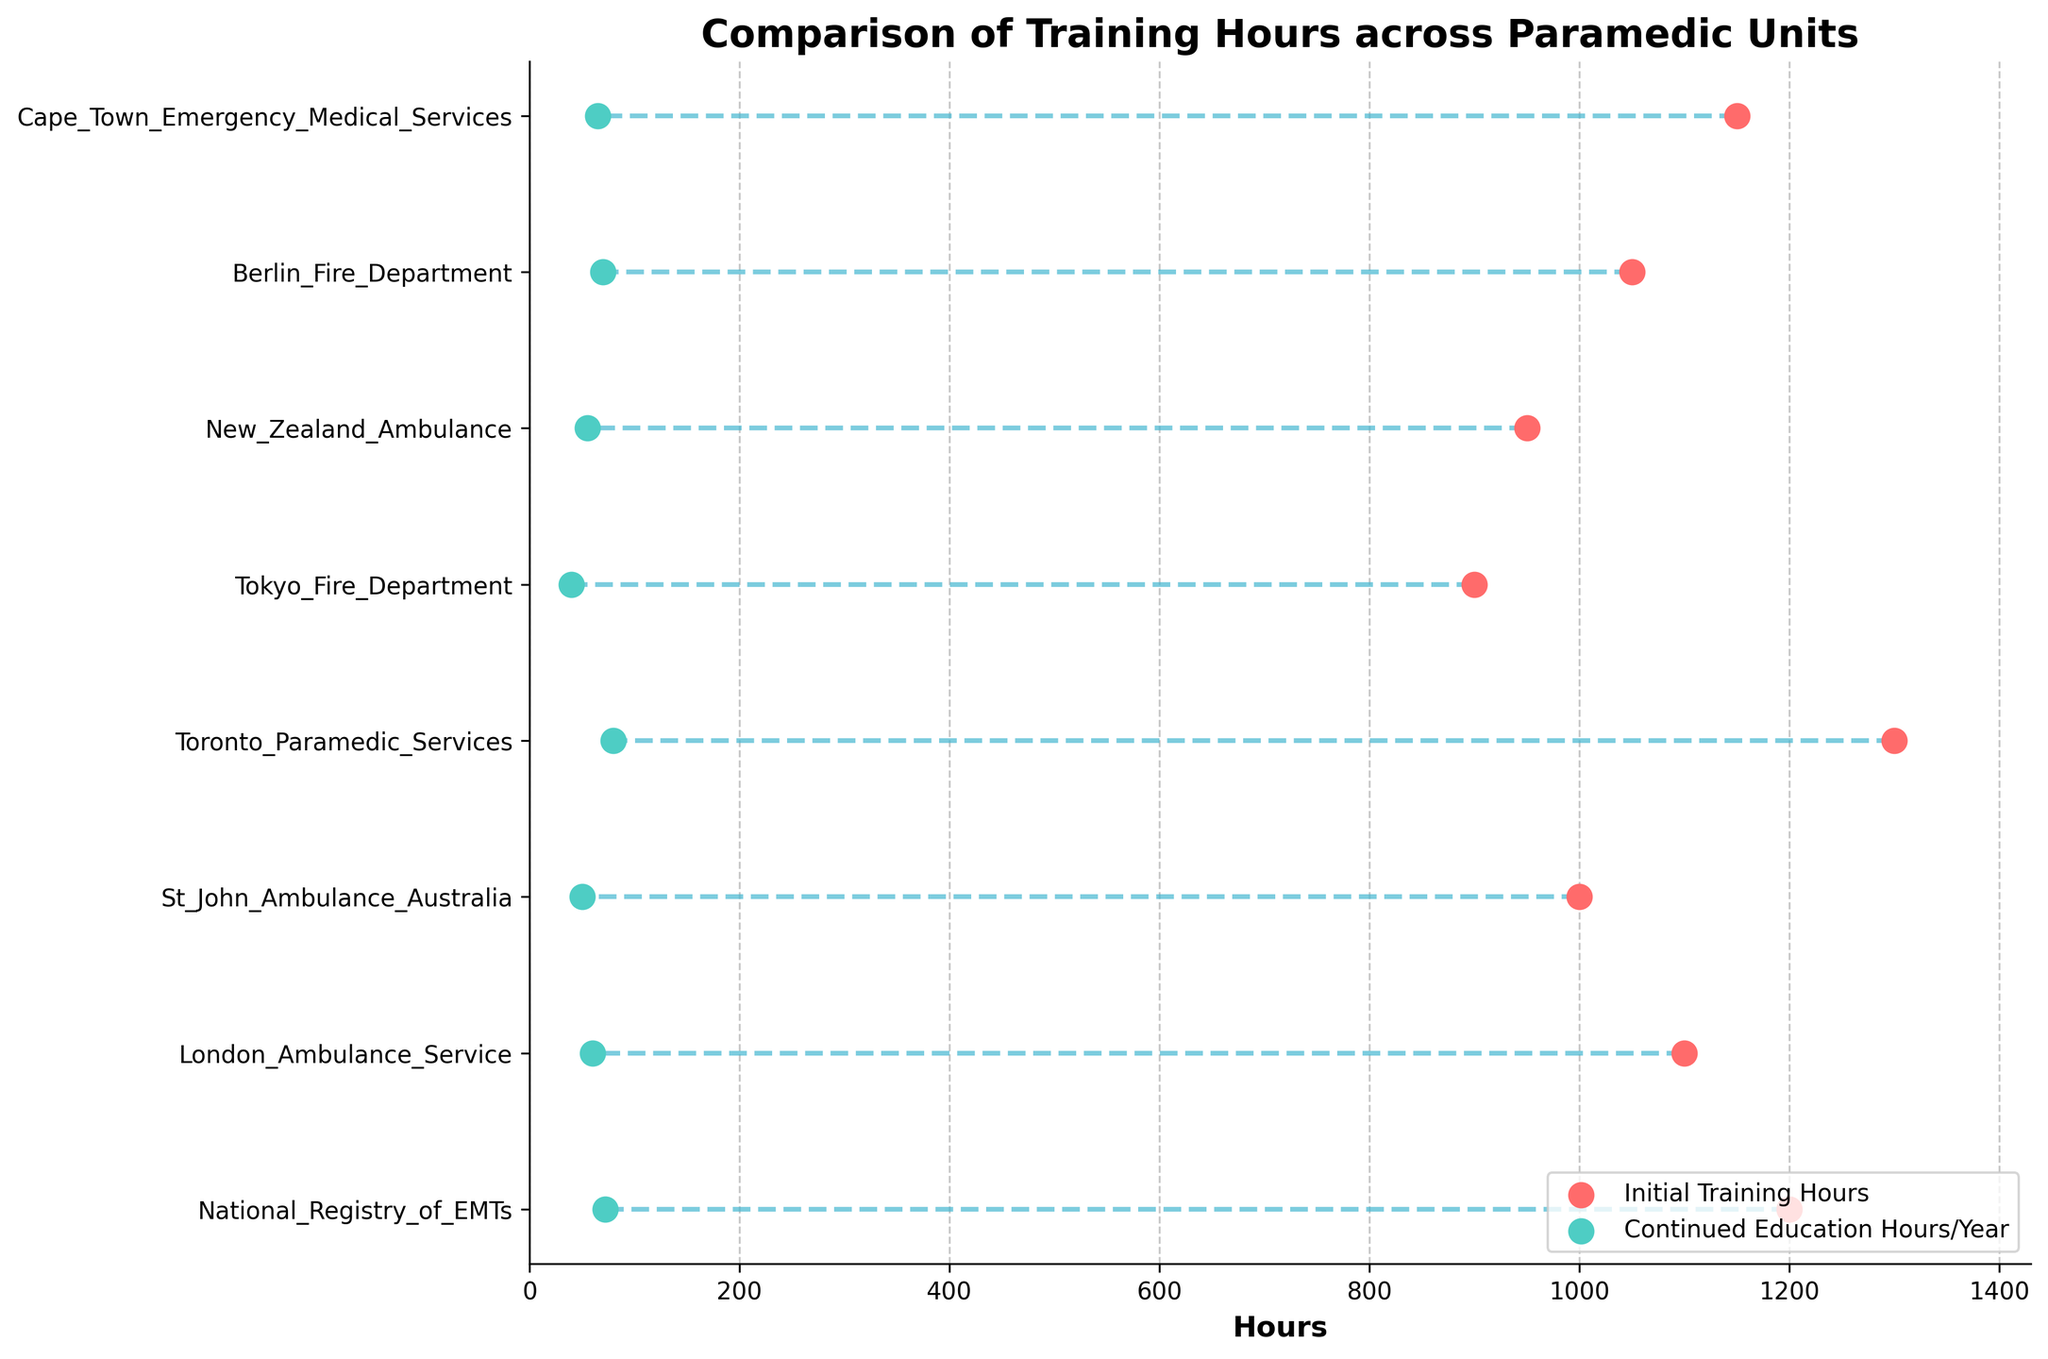How many different paramedic units are compared in the plot? Count the number of unique units listed on the y-axis of the plot
Answer: 8 What is the title of the plot? Read the title at the top of the plot
Answer: Comparison of Training Hours across Paramedic Units Which paramedic unit has the highest initial training hours? Identify the unit with the dot furthest to the right for initial training hours (red dot)
Answer: Toronto Paramedic Services What is the difference in continued education hours per year between Tokyo Fire Department and National Registry of EMTs? Subtract the continued education hours of Tokyo Fire Department (40) from National Registry of EMTs (72)
Answer: 32 How much initial training do paramedics in the Cape Town Emergency Medical Services receive? Identify the position of the red dot for Cape Town Emergency Medical Services on the x-axis
Answer: 1150 hours Which paramedic unit has the smallest difference in hours between initial training and continued education? Look for the shortest line connecting the red and teal dots for each unit and identify the corresponding unit
Answer: Tokyo Fire Department Rank the paramedic units from lowest to highest based on their continued education hours per year. Order the units based on the position of the teal dots on the x-axis
Answer: Tokyo Fire Department, St John Ambulance Australia, New Zealand Ambulance, London Ambulance Service, Cape Town Emergency Medical Services, Berlin Fire Department, National Registry of EMTs, Toronto Paramedic Services What is the average initial training hours across all paramedic units? Sum all the initial training hours and divide by the number of units: (1200+1100+1000+1300+900+950+1050+1150) / 8
Answer: 1168.75 hours Which paramedic unit has the greatest difference between initial training hours and continued education hours? Identify the unit with the longest line connecting the red and teal dots
Answer: Toronto Paramedic Services 